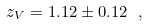Convert formula to latex. <formula><loc_0><loc_0><loc_500><loc_500>z _ { V } = 1 . 1 2 \pm 0 . 1 2 \ ,</formula> 